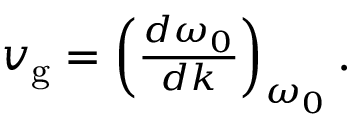Convert formula to latex. <formula><loc_0><loc_0><loc_500><loc_500>\begin{array} { r } { v _ { g } = \left ( \frac { d \omega _ { 0 } } { d k } \right ) _ { \omega _ { 0 } } . } \end{array}</formula> 